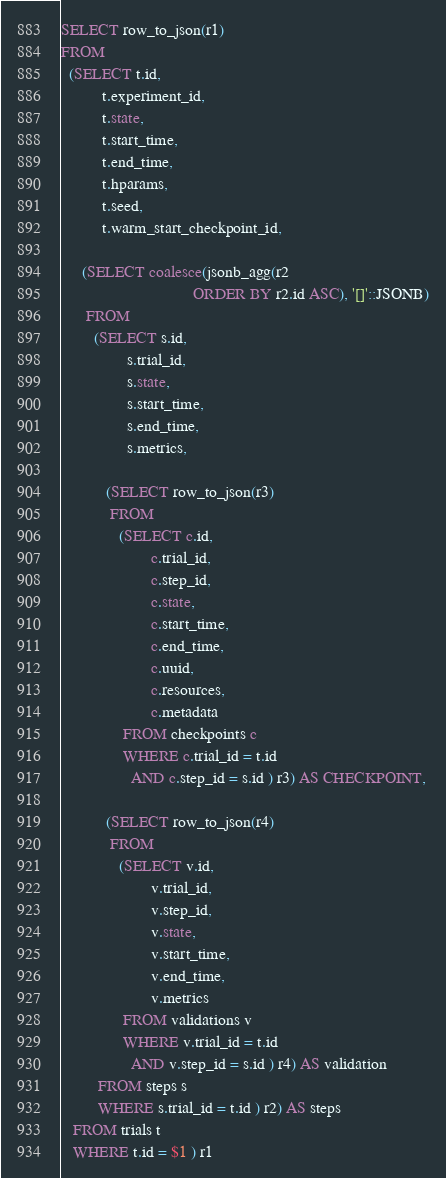Convert code to text. <code><loc_0><loc_0><loc_500><loc_500><_SQL_>SELECT row_to_json(r1)
FROM
  (SELECT t.id,
          t.experiment_id,
          t.state,
          t.start_time,
          t.end_time,
          t.hparams,
          t.seed,
          t.warm_start_checkpoint_id,

     (SELECT coalesce(jsonb_agg(r2
                                ORDER BY r2.id ASC), '[]'::JSONB)
      FROM
        (SELECT s.id,
                s.trial_id,
                s.state,
                s.start_time,
                s.end_time,
                s.metrics,

           (SELECT row_to_json(r3)
            FROM
              (SELECT c.id,
                      c.trial_id,
                      c.step_id,
                      c.state,
                      c.start_time,
                      c.end_time,
                      c.uuid,
                      c.resources,
                      c.metadata
               FROM checkpoints c
               WHERE c.trial_id = t.id
                 AND c.step_id = s.id ) r3) AS CHECKPOINT,

           (SELECT row_to_json(r4)
            FROM
              (SELECT v.id,
                      v.trial_id,
                      v.step_id,
                      v.state,
                      v.start_time,
                      v.end_time,
                      v.metrics
               FROM validations v
               WHERE v.trial_id = t.id
                 AND v.step_id = s.id ) r4) AS validation
         FROM steps s
         WHERE s.trial_id = t.id ) r2) AS steps
   FROM trials t
   WHERE t.id = $1 ) r1
</code> 